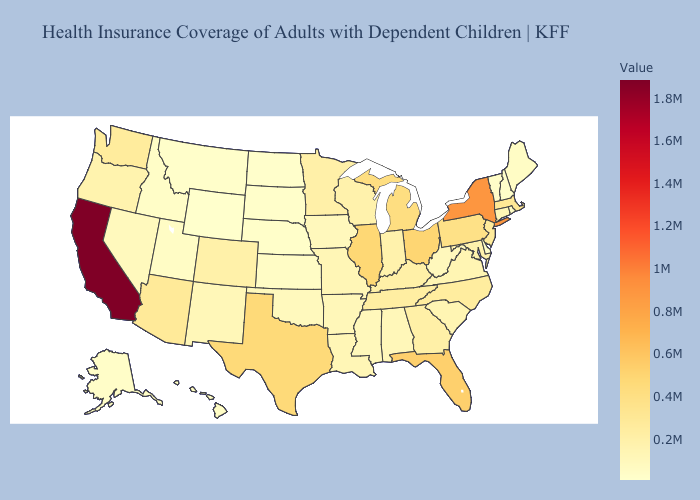Does California have the highest value in the USA?
Be succinct. Yes. Is the legend a continuous bar?
Write a very short answer. Yes. Which states have the lowest value in the MidWest?
Short answer required. North Dakota. Which states have the lowest value in the USA?
Concise answer only. Wyoming. Does South Carolina have the lowest value in the South?
Concise answer only. No. Which states have the lowest value in the USA?
Be succinct. Wyoming. Among the states that border Ohio , which have the lowest value?
Give a very brief answer. West Virginia. 